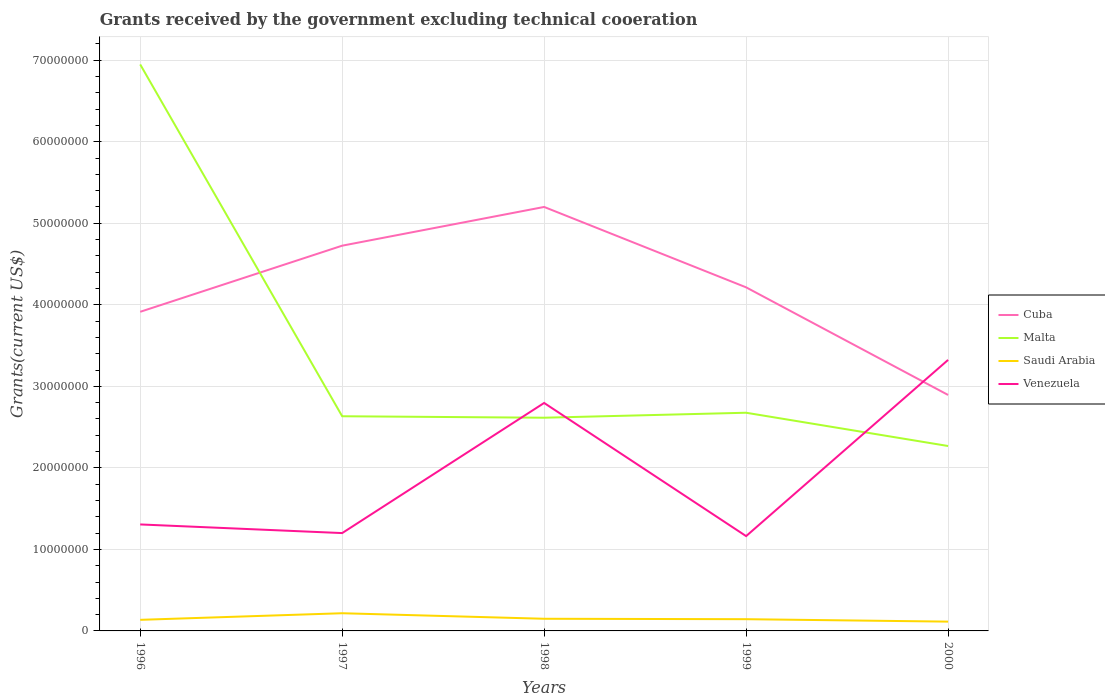How many different coloured lines are there?
Offer a terse response. 4. Does the line corresponding to Cuba intersect with the line corresponding to Venezuela?
Offer a very short reply. Yes. Is the number of lines equal to the number of legend labels?
Your response must be concise. Yes. Across all years, what is the maximum total grants received by the government in Venezuela?
Your response must be concise. 1.16e+07. In which year was the total grants received by the government in Saudi Arabia maximum?
Keep it short and to the point. 2000. What is the difference between the highest and the second highest total grants received by the government in Venezuela?
Your response must be concise. 2.16e+07. What is the difference between the highest and the lowest total grants received by the government in Venezuela?
Make the answer very short. 2. Is the total grants received by the government in Venezuela strictly greater than the total grants received by the government in Cuba over the years?
Offer a very short reply. No. How many years are there in the graph?
Your response must be concise. 5. Does the graph contain grids?
Offer a terse response. Yes. How many legend labels are there?
Give a very brief answer. 4. How are the legend labels stacked?
Make the answer very short. Vertical. What is the title of the graph?
Give a very brief answer. Grants received by the government excluding technical cooeration. Does "Latin America(all income levels)" appear as one of the legend labels in the graph?
Your answer should be compact. No. What is the label or title of the Y-axis?
Keep it short and to the point. Grants(current US$). What is the Grants(current US$) of Cuba in 1996?
Make the answer very short. 3.91e+07. What is the Grants(current US$) in Malta in 1996?
Offer a terse response. 6.95e+07. What is the Grants(current US$) in Saudi Arabia in 1996?
Your response must be concise. 1.36e+06. What is the Grants(current US$) of Venezuela in 1996?
Provide a succinct answer. 1.31e+07. What is the Grants(current US$) of Cuba in 1997?
Offer a terse response. 4.72e+07. What is the Grants(current US$) of Malta in 1997?
Keep it short and to the point. 2.63e+07. What is the Grants(current US$) of Saudi Arabia in 1997?
Your answer should be compact. 2.17e+06. What is the Grants(current US$) of Venezuela in 1997?
Your answer should be very brief. 1.20e+07. What is the Grants(current US$) in Cuba in 1998?
Offer a very short reply. 5.20e+07. What is the Grants(current US$) of Malta in 1998?
Offer a terse response. 2.62e+07. What is the Grants(current US$) in Saudi Arabia in 1998?
Offer a terse response. 1.49e+06. What is the Grants(current US$) of Venezuela in 1998?
Ensure brevity in your answer.  2.80e+07. What is the Grants(current US$) of Cuba in 1999?
Give a very brief answer. 4.21e+07. What is the Grants(current US$) of Malta in 1999?
Make the answer very short. 2.68e+07. What is the Grants(current US$) in Saudi Arabia in 1999?
Make the answer very short. 1.44e+06. What is the Grants(current US$) in Venezuela in 1999?
Ensure brevity in your answer.  1.16e+07. What is the Grants(current US$) in Cuba in 2000?
Ensure brevity in your answer.  2.89e+07. What is the Grants(current US$) of Malta in 2000?
Provide a short and direct response. 2.27e+07. What is the Grants(current US$) of Saudi Arabia in 2000?
Provide a short and direct response. 1.14e+06. What is the Grants(current US$) in Venezuela in 2000?
Offer a very short reply. 3.32e+07. Across all years, what is the maximum Grants(current US$) of Cuba?
Provide a succinct answer. 5.20e+07. Across all years, what is the maximum Grants(current US$) of Malta?
Your response must be concise. 6.95e+07. Across all years, what is the maximum Grants(current US$) in Saudi Arabia?
Your answer should be compact. 2.17e+06. Across all years, what is the maximum Grants(current US$) of Venezuela?
Your answer should be compact. 3.32e+07. Across all years, what is the minimum Grants(current US$) of Cuba?
Offer a very short reply. 2.89e+07. Across all years, what is the minimum Grants(current US$) of Malta?
Offer a very short reply. 2.27e+07. Across all years, what is the minimum Grants(current US$) in Saudi Arabia?
Provide a short and direct response. 1.14e+06. Across all years, what is the minimum Grants(current US$) of Venezuela?
Offer a very short reply. 1.16e+07. What is the total Grants(current US$) in Cuba in the graph?
Provide a succinct answer. 2.09e+08. What is the total Grants(current US$) of Malta in the graph?
Offer a terse response. 1.71e+08. What is the total Grants(current US$) in Saudi Arabia in the graph?
Give a very brief answer. 7.60e+06. What is the total Grants(current US$) in Venezuela in the graph?
Make the answer very short. 9.79e+07. What is the difference between the Grants(current US$) in Cuba in 1996 and that in 1997?
Make the answer very short. -8.11e+06. What is the difference between the Grants(current US$) of Malta in 1996 and that in 1997?
Give a very brief answer. 4.32e+07. What is the difference between the Grants(current US$) in Saudi Arabia in 1996 and that in 1997?
Keep it short and to the point. -8.10e+05. What is the difference between the Grants(current US$) of Venezuela in 1996 and that in 1997?
Ensure brevity in your answer.  1.06e+06. What is the difference between the Grants(current US$) in Cuba in 1996 and that in 1998?
Your answer should be very brief. -1.29e+07. What is the difference between the Grants(current US$) in Malta in 1996 and that in 1998?
Make the answer very short. 4.33e+07. What is the difference between the Grants(current US$) in Saudi Arabia in 1996 and that in 1998?
Give a very brief answer. -1.30e+05. What is the difference between the Grants(current US$) in Venezuela in 1996 and that in 1998?
Keep it short and to the point. -1.49e+07. What is the difference between the Grants(current US$) in Cuba in 1996 and that in 1999?
Make the answer very short. -3.00e+06. What is the difference between the Grants(current US$) in Malta in 1996 and that in 1999?
Provide a succinct answer. 4.27e+07. What is the difference between the Grants(current US$) of Saudi Arabia in 1996 and that in 1999?
Give a very brief answer. -8.00e+04. What is the difference between the Grants(current US$) in Venezuela in 1996 and that in 1999?
Give a very brief answer. 1.43e+06. What is the difference between the Grants(current US$) of Cuba in 1996 and that in 2000?
Your response must be concise. 1.02e+07. What is the difference between the Grants(current US$) in Malta in 1996 and that in 2000?
Your response must be concise. 4.68e+07. What is the difference between the Grants(current US$) of Venezuela in 1996 and that in 2000?
Provide a short and direct response. -2.02e+07. What is the difference between the Grants(current US$) in Cuba in 1997 and that in 1998?
Your response must be concise. -4.75e+06. What is the difference between the Grants(current US$) of Malta in 1997 and that in 1998?
Provide a succinct answer. 1.80e+05. What is the difference between the Grants(current US$) of Saudi Arabia in 1997 and that in 1998?
Your response must be concise. 6.80e+05. What is the difference between the Grants(current US$) in Venezuela in 1997 and that in 1998?
Offer a very short reply. -1.60e+07. What is the difference between the Grants(current US$) in Cuba in 1997 and that in 1999?
Your answer should be very brief. 5.11e+06. What is the difference between the Grants(current US$) of Malta in 1997 and that in 1999?
Ensure brevity in your answer.  -4.30e+05. What is the difference between the Grants(current US$) of Saudi Arabia in 1997 and that in 1999?
Your response must be concise. 7.30e+05. What is the difference between the Grants(current US$) of Cuba in 1997 and that in 2000?
Provide a short and direct response. 1.83e+07. What is the difference between the Grants(current US$) of Malta in 1997 and that in 2000?
Your response must be concise. 3.65e+06. What is the difference between the Grants(current US$) of Saudi Arabia in 1997 and that in 2000?
Make the answer very short. 1.03e+06. What is the difference between the Grants(current US$) of Venezuela in 1997 and that in 2000?
Keep it short and to the point. -2.12e+07. What is the difference between the Grants(current US$) of Cuba in 1998 and that in 1999?
Keep it short and to the point. 9.86e+06. What is the difference between the Grants(current US$) in Malta in 1998 and that in 1999?
Keep it short and to the point. -6.10e+05. What is the difference between the Grants(current US$) in Saudi Arabia in 1998 and that in 1999?
Offer a very short reply. 5.00e+04. What is the difference between the Grants(current US$) of Venezuela in 1998 and that in 1999?
Provide a succinct answer. 1.63e+07. What is the difference between the Grants(current US$) in Cuba in 1998 and that in 2000?
Ensure brevity in your answer.  2.31e+07. What is the difference between the Grants(current US$) in Malta in 1998 and that in 2000?
Give a very brief answer. 3.47e+06. What is the difference between the Grants(current US$) in Venezuela in 1998 and that in 2000?
Your response must be concise. -5.28e+06. What is the difference between the Grants(current US$) in Cuba in 1999 and that in 2000?
Keep it short and to the point. 1.32e+07. What is the difference between the Grants(current US$) of Malta in 1999 and that in 2000?
Give a very brief answer. 4.08e+06. What is the difference between the Grants(current US$) in Saudi Arabia in 1999 and that in 2000?
Offer a very short reply. 3.00e+05. What is the difference between the Grants(current US$) in Venezuela in 1999 and that in 2000?
Your answer should be very brief. -2.16e+07. What is the difference between the Grants(current US$) in Cuba in 1996 and the Grants(current US$) in Malta in 1997?
Your answer should be compact. 1.28e+07. What is the difference between the Grants(current US$) of Cuba in 1996 and the Grants(current US$) of Saudi Arabia in 1997?
Your answer should be compact. 3.70e+07. What is the difference between the Grants(current US$) in Cuba in 1996 and the Grants(current US$) in Venezuela in 1997?
Offer a very short reply. 2.71e+07. What is the difference between the Grants(current US$) of Malta in 1996 and the Grants(current US$) of Saudi Arabia in 1997?
Your response must be concise. 6.73e+07. What is the difference between the Grants(current US$) in Malta in 1996 and the Grants(current US$) in Venezuela in 1997?
Offer a terse response. 5.75e+07. What is the difference between the Grants(current US$) of Saudi Arabia in 1996 and the Grants(current US$) of Venezuela in 1997?
Your answer should be compact. -1.06e+07. What is the difference between the Grants(current US$) of Cuba in 1996 and the Grants(current US$) of Malta in 1998?
Provide a short and direct response. 1.30e+07. What is the difference between the Grants(current US$) in Cuba in 1996 and the Grants(current US$) in Saudi Arabia in 1998?
Ensure brevity in your answer.  3.76e+07. What is the difference between the Grants(current US$) in Cuba in 1996 and the Grants(current US$) in Venezuela in 1998?
Keep it short and to the point. 1.12e+07. What is the difference between the Grants(current US$) in Malta in 1996 and the Grants(current US$) in Saudi Arabia in 1998?
Give a very brief answer. 6.80e+07. What is the difference between the Grants(current US$) in Malta in 1996 and the Grants(current US$) in Venezuela in 1998?
Make the answer very short. 4.15e+07. What is the difference between the Grants(current US$) in Saudi Arabia in 1996 and the Grants(current US$) in Venezuela in 1998?
Provide a short and direct response. -2.66e+07. What is the difference between the Grants(current US$) in Cuba in 1996 and the Grants(current US$) in Malta in 1999?
Your answer should be compact. 1.24e+07. What is the difference between the Grants(current US$) of Cuba in 1996 and the Grants(current US$) of Saudi Arabia in 1999?
Ensure brevity in your answer.  3.77e+07. What is the difference between the Grants(current US$) in Cuba in 1996 and the Grants(current US$) in Venezuela in 1999?
Make the answer very short. 2.75e+07. What is the difference between the Grants(current US$) of Malta in 1996 and the Grants(current US$) of Saudi Arabia in 1999?
Make the answer very short. 6.80e+07. What is the difference between the Grants(current US$) of Malta in 1996 and the Grants(current US$) of Venezuela in 1999?
Make the answer very short. 5.78e+07. What is the difference between the Grants(current US$) of Saudi Arabia in 1996 and the Grants(current US$) of Venezuela in 1999?
Offer a terse response. -1.03e+07. What is the difference between the Grants(current US$) in Cuba in 1996 and the Grants(current US$) in Malta in 2000?
Provide a succinct answer. 1.65e+07. What is the difference between the Grants(current US$) of Cuba in 1996 and the Grants(current US$) of Saudi Arabia in 2000?
Your response must be concise. 3.80e+07. What is the difference between the Grants(current US$) of Cuba in 1996 and the Grants(current US$) of Venezuela in 2000?
Your answer should be compact. 5.90e+06. What is the difference between the Grants(current US$) in Malta in 1996 and the Grants(current US$) in Saudi Arabia in 2000?
Make the answer very short. 6.83e+07. What is the difference between the Grants(current US$) in Malta in 1996 and the Grants(current US$) in Venezuela in 2000?
Your answer should be compact. 3.62e+07. What is the difference between the Grants(current US$) in Saudi Arabia in 1996 and the Grants(current US$) in Venezuela in 2000?
Ensure brevity in your answer.  -3.19e+07. What is the difference between the Grants(current US$) in Cuba in 1997 and the Grants(current US$) in Malta in 1998?
Ensure brevity in your answer.  2.11e+07. What is the difference between the Grants(current US$) in Cuba in 1997 and the Grants(current US$) in Saudi Arabia in 1998?
Ensure brevity in your answer.  4.58e+07. What is the difference between the Grants(current US$) in Cuba in 1997 and the Grants(current US$) in Venezuela in 1998?
Provide a succinct answer. 1.93e+07. What is the difference between the Grants(current US$) in Malta in 1997 and the Grants(current US$) in Saudi Arabia in 1998?
Ensure brevity in your answer.  2.48e+07. What is the difference between the Grants(current US$) of Malta in 1997 and the Grants(current US$) of Venezuela in 1998?
Your answer should be very brief. -1.63e+06. What is the difference between the Grants(current US$) of Saudi Arabia in 1997 and the Grants(current US$) of Venezuela in 1998?
Give a very brief answer. -2.58e+07. What is the difference between the Grants(current US$) of Cuba in 1997 and the Grants(current US$) of Malta in 1999?
Offer a very short reply. 2.05e+07. What is the difference between the Grants(current US$) in Cuba in 1997 and the Grants(current US$) in Saudi Arabia in 1999?
Your answer should be very brief. 4.58e+07. What is the difference between the Grants(current US$) in Cuba in 1997 and the Grants(current US$) in Venezuela in 1999?
Your answer should be compact. 3.56e+07. What is the difference between the Grants(current US$) of Malta in 1997 and the Grants(current US$) of Saudi Arabia in 1999?
Your response must be concise. 2.49e+07. What is the difference between the Grants(current US$) in Malta in 1997 and the Grants(current US$) in Venezuela in 1999?
Your answer should be compact. 1.47e+07. What is the difference between the Grants(current US$) in Saudi Arabia in 1997 and the Grants(current US$) in Venezuela in 1999?
Make the answer very short. -9.46e+06. What is the difference between the Grants(current US$) of Cuba in 1997 and the Grants(current US$) of Malta in 2000?
Your answer should be compact. 2.46e+07. What is the difference between the Grants(current US$) in Cuba in 1997 and the Grants(current US$) in Saudi Arabia in 2000?
Your answer should be compact. 4.61e+07. What is the difference between the Grants(current US$) of Cuba in 1997 and the Grants(current US$) of Venezuela in 2000?
Your response must be concise. 1.40e+07. What is the difference between the Grants(current US$) of Malta in 1997 and the Grants(current US$) of Saudi Arabia in 2000?
Provide a short and direct response. 2.52e+07. What is the difference between the Grants(current US$) in Malta in 1997 and the Grants(current US$) in Venezuela in 2000?
Offer a terse response. -6.91e+06. What is the difference between the Grants(current US$) of Saudi Arabia in 1997 and the Grants(current US$) of Venezuela in 2000?
Keep it short and to the point. -3.11e+07. What is the difference between the Grants(current US$) in Cuba in 1998 and the Grants(current US$) in Malta in 1999?
Give a very brief answer. 2.52e+07. What is the difference between the Grants(current US$) in Cuba in 1998 and the Grants(current US$) in Saudi Arabia in 1999?
Ensure brevity in your answer.  5.06e+07. What is the difference between the Grants(current US$) of Cuba in 1998 and the Grants(current US$) of Venezuela in 1999?
Ensure brevity in your answer.  4.04e+07. What is the difference between the Grants(current US$) of Malta in 1998 and the Grants(current US$) of Saudi Arabia in 1999?
Your response must be concise. 2.47e+07. What is the difference between the Grants(current US$) of Malta in 1998 and the Grants(current US$) of Venezuela in 1999?
Your response must be concise. 1.45e+07. What is the difference between the Grants(current US$) in Saudi Arabia in 1998 and the Grants(current US$) in Venezuela in 1999?
Offer a very short reply. -1.01e+07. What is the difference between the Grants(current US$) of Cuba in 1998 and the Grants(current US$) of Malta in 2000?
Offer a terse response. 2.93e+07. What is the difference between the Grants(current US$) in Cuba in 1998 and the Grants(current US$) in Saudi Arabia in 2000?
Keep it short and to the point. 5.09e+07. What is the difference between the Grants(current US$) of Cuba in 1998 and the Grants(current US$) of Venezuela in 2000?
Give a very brief answer. 1.88e+07. What is the difference between the Grants(current US$) of Malta in 1998 and the Grants(current US$) of Saudi Arabia in 2000?
Your answer should be very brief. 2.50e+07. What is the difference between the Grants(current US$) in Malta in 1998 and the Grants(current US$) in Venezuela in 2000?
Give a very brief answer. -7.09e+06. What is the difference between the Grants(current US$) in Saudi Arabia in 1998 and the Grants(current US$) in Venezuela in 2000?
Give a very brief answer. -3.18e+07. What is the difference between the Grants(current US$) in Cuba in 1999 and the Grants(current US$) in Malta in 2000?
Ensure brevity in your answer.  1.95e+07. What is the difference between the Grants(current US$) of Cuba in 1999 and the Grants(current US$) of Saudi Arabia in 2000?
Offer a very short reply. 4.10e+07. What is the difference between the Grants(current US$) in Cuba in 1999 and the Grants(current US$) in Venezuela in 2000?
Make the answer very short. 8.90e+06. What is the difference between the Grants(current US$) of Malta in 1999 and the Grants(current US$) of Saudi Arabia in 2000?
Give a very brief answer. 2.56e+07. What is the difference between the Grants(current US$) in Malta in 1999 and the Grants(current US$) in Venezuela in 2000?
Offer a very short reply. -6.48e+06. What is the difference between the Grants(current US$) of Saudi Arabia in 1999 and the Grants(current US$) of Venezuela in 2000?
Your answer should be very brief. -3.18e+07. What is the average Grants(current US$) of Cuba per year?
Make the answer very short. 4.19e+07. What is the average Grants(current US$) in Malta per year?
Offer a terse response. 3.43e+07. What is the average Grants(current US$) of Saudi Arabia per year?
Offer a very short reply. 1.52e+06. What is the average Grants(current US$) in Venezuela per year?
Ensure brevity in your answer.  1.96e+07. In the year 1996, what is the difference between the Grants(current US$) of Cuba and Grants(current US$) of Malta?
Keep it short and to the point. -3.03e+07. In the year 1996, what is the difference between the Grants(current US$) of Cuba and Grants(current US$) of Saudi Arabia?
Your answer should be compact. 3.78e+07. In the year 1996, what is the difference between the Grants(current US$) of Cuba and Grants(current US$) of Venezuela?
Your response must be concise. 2.61e+07. In the year 1996, what is the difference between the Grants(current US$) of Malta and Grants(current US$) of Saudi Arabia?
Offer a very short reply. 6.81e+07. In the year 1996, what is the difference between the Grants(current US$) of Malta and Grants(current US$) of Venezuela?
Your answer should be compact. 5.64e+07. In the year 1996, what is the difference between the Grants(current US$) of Saudi Arabia and Grants(current US$) of Venezuela?
Provide a short and direct response. -1.17e+07. In the year 1997, what is the difference between the Grants(current US$) in Cuba and Grants(current US$) in Malta?
Provide a short and direct response. 2.09e+07. In the year 1997, what is the difference between the Grants(current US$) in Cuba and Grants(current US$) in Saudi Arabia?
Keep it short and to the point. 4.51e+07. In the year 1997, what is the difference between the Grants(current US$) in Cuba and Grants(current US$) in Venezuela?
Make the answer very short. 3.52e+07. In the year 1997, what is the difference between the Grants(current US$) in Malta and Grants(current US$) in Saudi Arabia?
Your answer should be compact. 2.42e+07. In the year 1997, what is the difference between the Grants(current US$) in Malta and Grants(current US$) in Venezuela?
Keep it short and to the point. 1.43e+07. In the year 1997, what is the difference between the Grants(current US$) of Saudi Arabia and Grants(current US$) of Venezuela?
Ensure brevity in your answer.  -9.83e+06. In the year 1998, what is the difference between the Grants(current US$) of Cuba and Grants(current US$) of Malta?
Provide a succinct answer. 2.58e+07. In the year 1998, what is the difference between the Grants(current US$) in Cuba and Grants(current US$) in Saudi Arabia?
Offer a terse response. 5.05e+07. In the year 1998, what is the difference between the Grants(current US$) in Cuba and Grants(current US$) in Venezuela?
Offer a very short reply. 2.40e+07. In the year 1998, what is the difference between the Grants(current US$) of Malta and Grants(current US$) of Saudi Arabia?
Offer a terse response. 2.47e+07. In the year 1998, what is the difference between the Grants(current US$) in Malta and Grants(current US$) in Venezuela?
Offer a very short reply. -1.81e+06. In the year 1998, what is the difference between the Grants(current US$) of Saudi Arabia and Grants(current US$) of Venezuela?
Give a very brief answer. -2.65e+07. In the year 1999, what is the difference between the Grants(current US$) in Cuba and Grants(current US$) in Malta?
Provide a succinct answer. 1.54e+07. In the year 1999, what is the difference between the Grants(current US$) of Cuba and Grants(current US$) of Saudi Arabia?
Your answer should be compact. 4.07e+07. In the year 1999, what is the difference between the Grants(current US$) of Cuba and Grants(current US$) of Venezuela?
Offer a terse response. 3.05e+07. In the year 1999, what is the difference between the Grants(current US$) of Malta and Grants(current US$) of Saudi Arabia?
Keep it short and to the point. 2.53e+07. In the year 1999, what is the difference between the Grants(current US$) of Malta and Grants(current US$) of Venezuela?
Provide a short and direct response. 1.51e+07. In the year 1999, what is the difference between the Grants(current US$) in Saudi Arabia and Grants(current US$) in Venezuela?
Your response must be concise. -1.02e+07. In the year 2000, what is the difference between the Grants(current US$) of Cuba and Grants(current US$) of Malta?
Your answer should be compact. 6.26e+06. In the year 2000, what is the difference between the Grants(current US$) of Cuba and Grants(current US$) of Saudi Arabia?
Make the answer very short. 2.78e+07. In the year 2000, what is the difference between the Grants(current US$) in Cuba and Grants(current US$) in Venezuela?
Offer a very short reply. -4.30e+06. In the year 2000, what is the difference between the Grants(current US$) in Malta and Grants(current US$) in Saudi Arabia?
Make the answer very short. 2.15e+07. In the year 2000, what is the difference between the Grants(current US$) of Malta and Grants(current US$) of Venezuela?
Ensure brevity in your answer.  -1.06e+07. In the year 2000, what is the difference between the Grants(current US$) of Saudi Arabia and Grants(current US$) of Venezuela?
Your answer should be compact. -3.21e+07. What is the ratio of the Grants(current US$) of Cuba in 1996 to that in 1997?
Provide a short and direct response. 0.83. What is the ratio of the Grants(current US$) of Malta in 1996 to that in 1997?
Your answer should be very brief. 2.64. What is the ratio of the Grants(current US$) in Saudi Arabia in 1996 to that in 1997?
Keep it short and to the point. 0.63. What is the ratio of the Grants(current US$) in Venezuela in 1996 to that in 1997?
Make the answer very short. 1.09. What is the ratio of the Grants(current US$) of Cuba in 1996 to that in 1998?
Provide a short and direct response. 0.75. What is the ratio of the Grants(current US$) of Malta in 1996 to that in 1998?
Provide a short and direct response. 2.66. What is the ratio of the Grants(current US$) of Saudi Arabia in 1996 to that in 1998?
Your answer should be compact. 0.91. What is the ratio of the Grants(current US$) in Venezuela in 1996 to that in 1998?
Provide a succinct answer. 0.47. What is the ratio of the Grants(current US$) of Cuba in 1996 to that in 1999?
Your answer should be very brief. 0.93. What is the ratio of the Grants(current US$) in Malta in 1996 to that in 1999?
Offer a very short reply. 2.6. What is the ratio of the Grants(current US$) of Venezuela in 1996 to that in 1999?
Offer a terse response. 1.12. What is the ratio of the Grants(current US$) of Cuba in 1996 to that in 2000?
Your response must be concise. 1.35. What is the ratio of the Grants(current US$) in Malta in 1996 to that in 2000?
Provide a short and direct response. 3.06. What is the ratio of the Grants(current US$) in Saudi Arabia in 1996 to that in 2000?
Provide a short and direct response. 1.19. What is the ratio of the Grants(current US$) in Venezuela in 1996 to that in 2000?
Your response must be concise. 0.39. What is the ratio of the Grants(current US$) in Cuba in 1997 to that in 1998?
Provide a succinct answer. 0.91. What is the ratio of the Grants(current US$) of Malta in 1997 to that in 1998?
Make the answer very short. 1.01. What is the ratio of the Grants(current US$) of Saudi Arabia in 1997 to that in 1998?
Keep it short and to the point. 1.46. What is the ratio of the Grants(current US$) of Venezuela in 1997 to that in 1998?
Your answer should be compact. 0.43. What is the ratio of the Grants(current US$) in Cuba in 1997 to that in 1999?
Your response must be concise. 1.12. What is the ratio of the Grants(current US$) of Malta in 1997 to that in 1999?
Ensure brevity in your answer.  0.98. What is the ratio of the Grants(current US$) in Saudi Arabia in 1997 to that in 1999?
Provide a short and direct response. 1.51. What is the ratio of the Grants(current US$) in Venezuela in 1997 to that in 1999?
Provide a succinct answer. 1.03. What is the ratio of the Grants(current US$) in Cuba in 1997 to that in 2000?
Provide a succinct answer. 1.63. What is the ratio of the Grants(current US$) of Malta in 1997 to that in 2000?
Give a very brief answer. 1.16. What is the ratio of the Grants(current US$) in Saudi Arabia in 1997 to that in 2000?
Offer a terse response. 1.9. What is the ratio of the Grants(current US$) in Venezuela in 1997 to that in 2000?
Your answer should be very brief. 0.36. What is the ratio of the Grants(current US$) in Cuba in 1998 to that in 1999?
Make the answer very short. 1.23. What is the ratio of the Grants(current US$) in Malta in 1998 to that in 1999?
Your response must be concise. 0.98. What is the ratio of the Grants(current US$) of Saudi Arabia in 1998 to that in 1999?
Offer a very short reply. 1.03. What is the ratio of the Grants(current US$) in Venezuela in 1998 to that in 1999?
Ensure brevity in your answer.  2.4. What is the ratio of the Grants(current US$) in Cuba in 1998 to that in 2000?
Your response must be concise. 1.8. What is the ratio of the Grants(current US$) in Malta in 1998 to that in 2000?
Provide a short and direct response. 1.15. What is the ratio of the Grants(current US$) in Saudi Arabia in 1998 to that in 2000?
Offer a very short reply. 1.31. What is the ratio of the Grants(current US$) in Venezuela in 1998 to that in 2000?
Your answer should be very brief. 0.84. What is the ratio of the Grants(current US$) in Cuba in 1999 to that in 2000?
Keep it short and to the point. 1.46. What is the ratio of the Grants(current US$) in Malta in 1999 to that in 2000?
Offer a terse response. 1.18. What is the ratio of the Grants(current US$) in Saudi Arabia in 1999 to that in 2000?
Your answer should be very brief. 1.26. What is the ratio of the Grants(current US$) of Venezuela in 1999 to that in 2000?
Offer a terse response. 0.35. What is the difference between the highest and the second highest Grants(current US$) in Cuba?
Make the answer very short. 4.75e+06. What is the difference between the highest and the second highest Grants(current US$) of Malta?
Ensure brevity in your answer.  4.27e+07. What is the difference between the highest and the second highest Grants(current US$) in Saudi Arabia?
Your response must be concise. 6.80e+05. What is the difference between the highest and the second highest Grants(current US$) in Venezuela?
Your answer should be very brief. 5.28e+06. What is the difference between the highest and the lowest Grants(current US$) of Cuba?
Give a very brief answer. 2.31e+07. What is the difference between the highest and the lowest Grants(current US$) of Malta?
Provide a short and direct response. 4.68e+07. What is the difference between the highest and the lowest Grants(current US$) of Saudi Arabia?
Ensure brevity in your answer.  1.03e+06. What is the difference between the highest and the lowest Grants(current US$) of Venezuela?
Your answer should be very brief. 2.16e+07. 